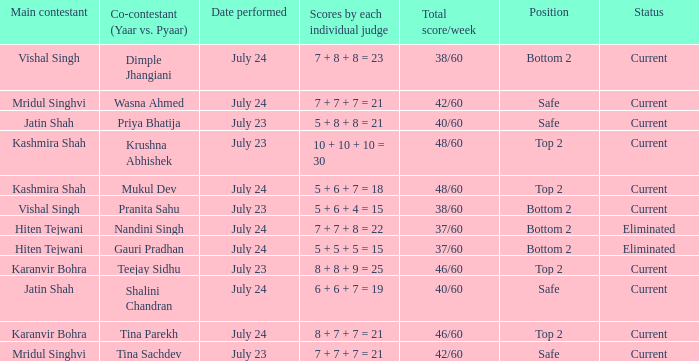Who is the main contestant with scores by each individual judge of 8 + 7 + 7 = 21? Karanvir Bohra. 